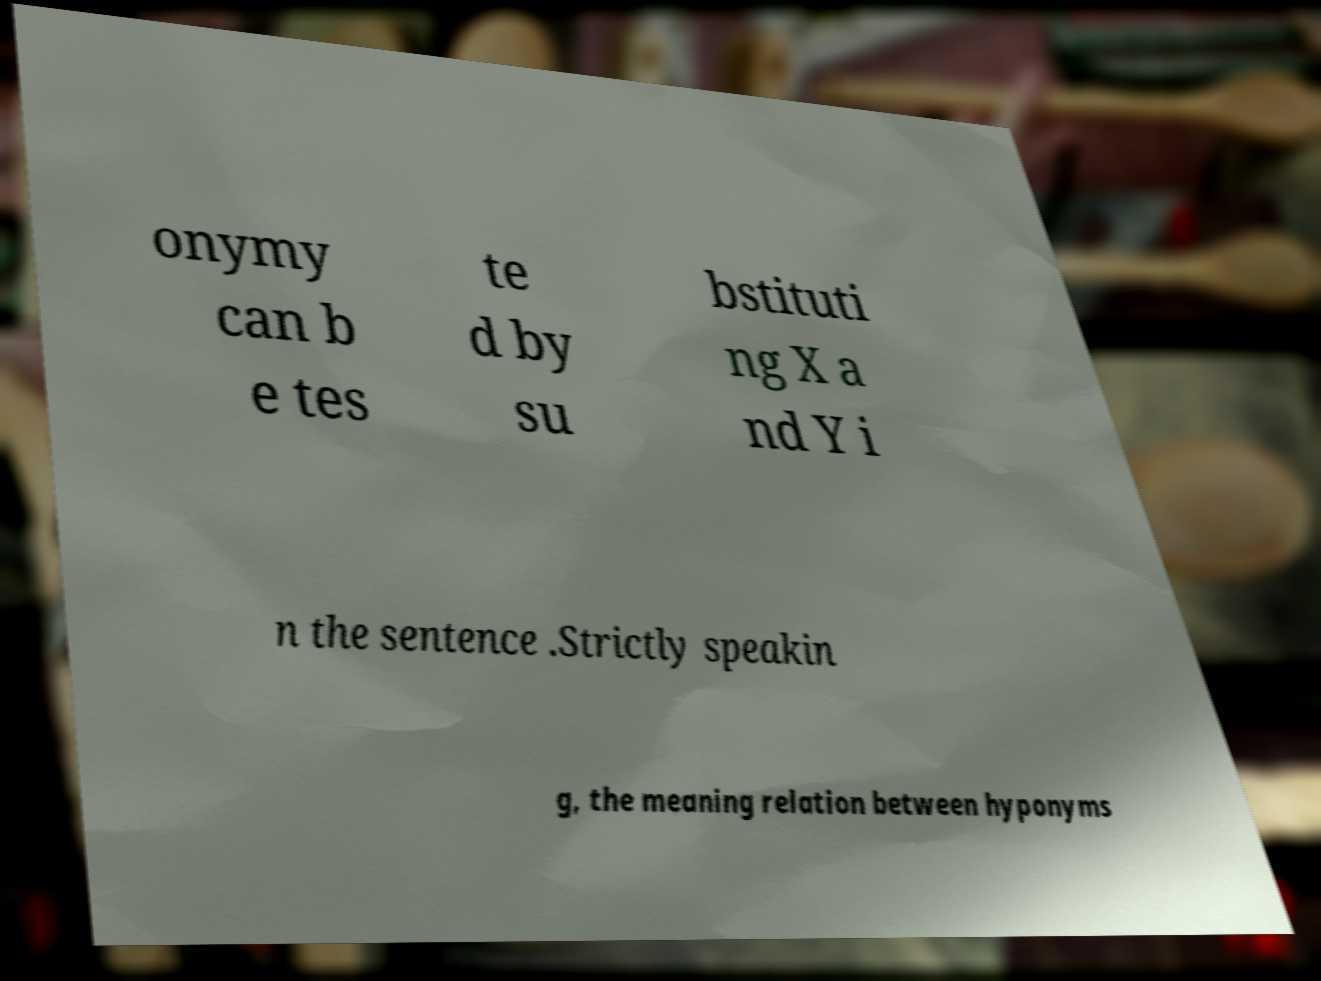For documentation purposes, I need the text within this image transcribed. Could you provide that? onymy can b e tes te d by su bstituti ng X a nd Y i n the sentence .Strictly speakin g, the meaning relation between hyponyms 